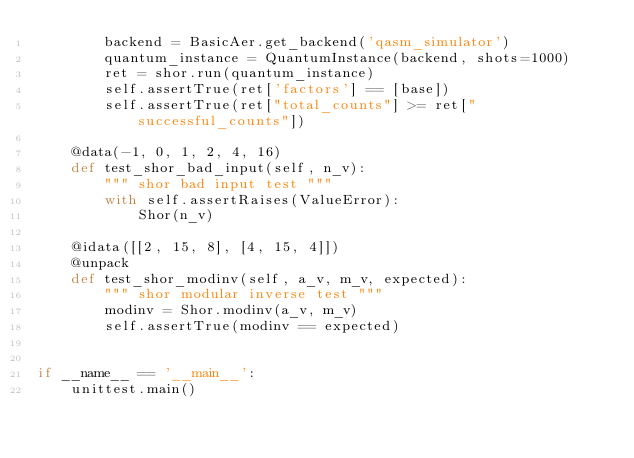Convert code to text. <code><loc_0><loc_0><loc_500><loc_500><_Python_>        backend = BasicAer.get_backend('qasm_simulator')
        quantum_instance = QuantumInstance(backend, shots=1000)
        ret = shor.run(quantum_instance)
        self.assertTrue(ret['factors'] == [base])
        self.assertTrue(ret["total_counts"] >= ret["successful_counts"])

    @data(-1, 0, 1, 2, 4, 16)
    def test_shor_bad_input(self, n_v):
        """ shor bad input test """
        with self.assertRaises(ValueError):
            Shor(n_v)

    @idata([[2, 15, 8], [4, 15, 4]])
    @unpack
    def test_shor_modinv(self, a_v, m_v, expected):
        """ shor modular inverse test """
        modinv = Shor.modinv(a_v, m_v)
        self.assertTrue(modinv == expected)


if __name__ == '__main__':
    unittest.main()
</code> 